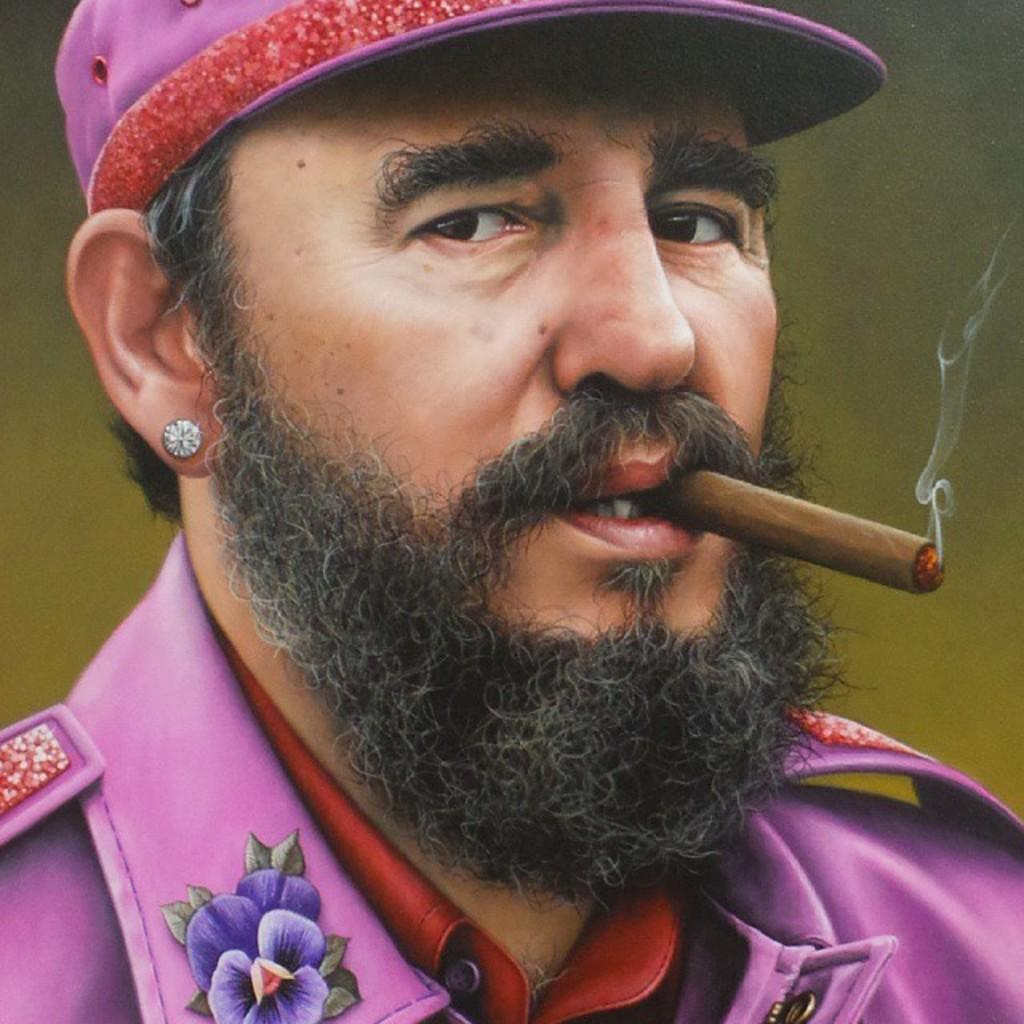Who is present in the image? There is a man in the image. What is the man wearing on his head? The man is wearing a cap. What is the man holding in his mouth? The man has a cigar in his mouth. What can be seen coming from the cigar? There is smoke visible in the image. What subject is the man teaching in the image? There is no indication in the image that the man is teaching any subject. What type of face does the man have in the image? The image does not provide enough detail to describe the man's facial features. 